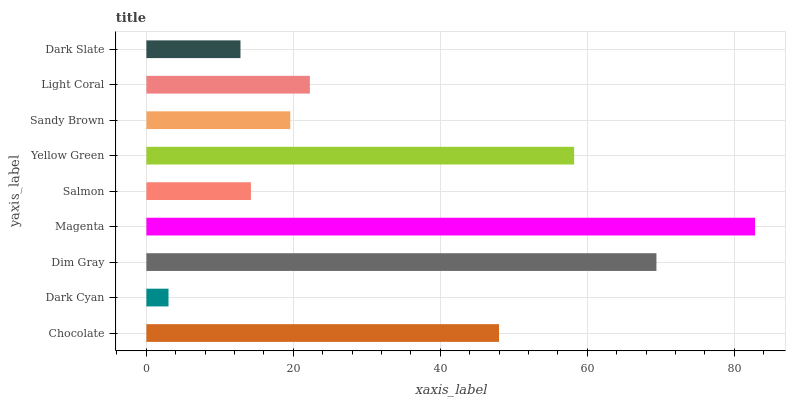Is Dark Cyan the minimum?
Answer yes or no. Yes. Is Magenta the maximum?
Answer yes or no. Yes. Is Dim Gray the minimum?
Answer yes or no. No. Is Dim Gray the maximum?
Answer yes or no. No. Is Dim Gray greater than Dark Cyan?
Answer yes or no. Yes. Is Dark Cyan less than Dim Gray?
Answer yes or no. Yes. Is Dark Cyan greater than Dim Gray?
Answer yes or no. No. Is Dim Gray less than Dark Cyan?
Answer yes or no. No. Is Light Coral the high median?
Answer yes or no. Yes. Is Light Coral the low median?
Answer yes or no. Yes. Is Dim Gray the high median?
Answer yes or no. No. Is Dark Slate the low median?
Answer yes or no. No. 